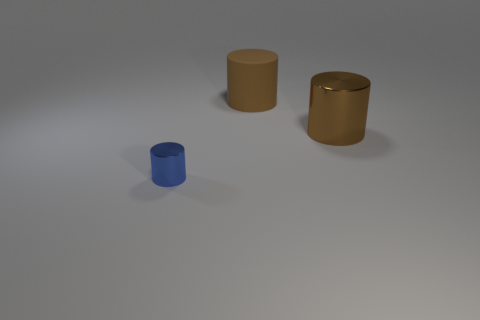Does the metal cylinder that is on the right side of the blue metal cylinder have the same color as the small metallic cylinder?
Your answer should be very brief. No. How many metallic objects are either brown things or yellow blocks?
Offer a terse response. 1. What shape is the tiny metallic thing?
Offer a very short reply. Cylinder. Is there any other thing that is the same material as the small blue cylinder?
Your answer should be very brief. Yes. There is a object on the right side of the big brown thing that is left of the big metal thing; is there a blue thing in front of it?
Keep it short and to the point. Yes. How many other things are the same shape as the big rubber object?
Offer a terse response. 2. What is the shape of the object that is behind the tiny blue shiny cylinder and to the left of the big brown metal cylinder?
Offer a very short reply. Cylinder. What color is the large shiny thing in front of the big object that is left of the metallic cylinder that is right of the tiny blue metal thing?
Your answer should be very brief. Brown. Is the number of cylinders behind the small cylinder greater than the number of brown metallic cylinders behind the matte object?
Your answer should be very brief. Yes. How many other objects are the same size as the brown metal cylinder?
Your answer should be very brief. 1. 